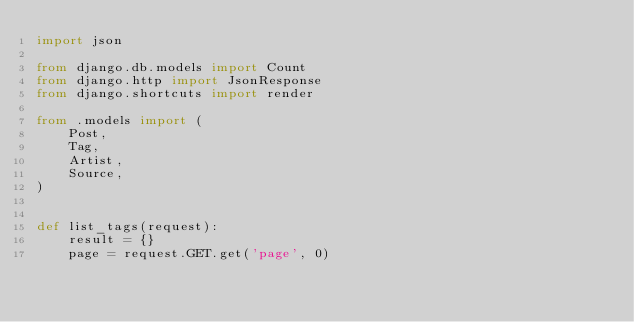Convert code to text. <code><loc_0><loc_0><loc_500><loc_500><_Python_>import json

from django.db.models import Count
from django.http import JsonResponse
from django.shortcuts import render

from .models import (
    Post,
    Tag,
    Artist,
    Source,
)


def list_tags(request):
    result = {}
    page = request.GET.get('page', 0)</code> 